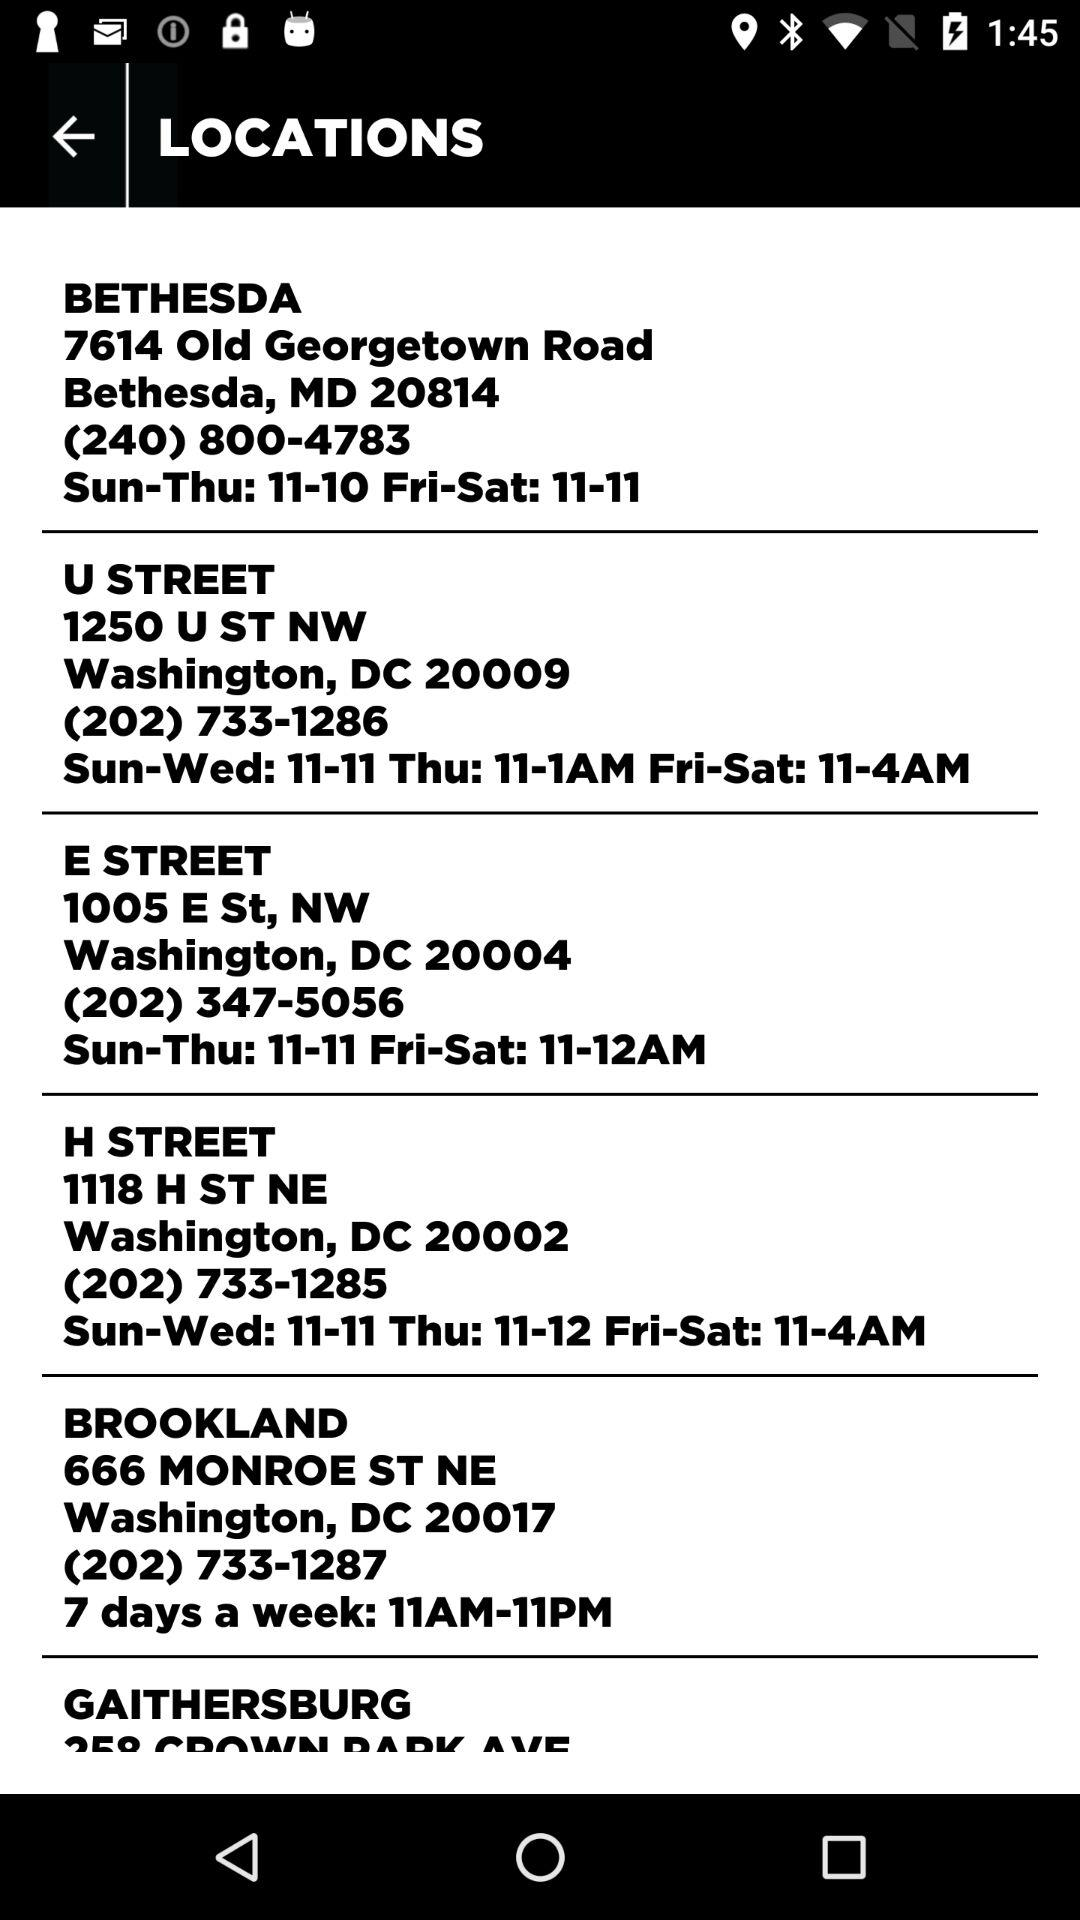What is the address of "U STREET"? The address is 1250 U Street NW, Washington, DC 20009. 